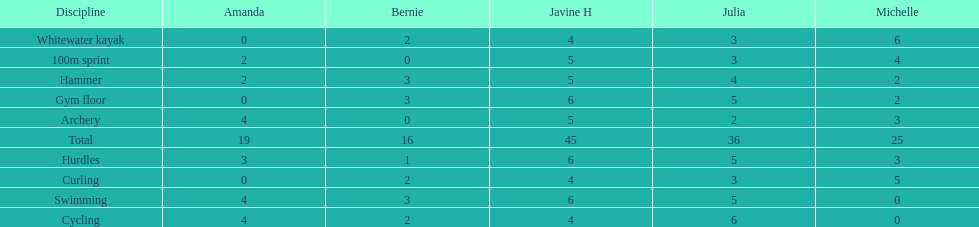What is the average score on 100m sprint? 2.8. Can you parse all the data within this table? {'header': ['Discipline', 'Amanda', 'Bernie', 'Javine H', 'Julia', 'Michelle'], 'rows': [['Whitewater kayak', '0', '2', '4', '3', '6'], ['100m sprint', '2', '0', '5', '3', '4'], ['Hammer', '2', '3', '5', '4', '2'], ['Gym floor', '0', '3', '6', '5', '2'], ['Archery', '4', '0', '5', '2', '3'], ['Total', '19', '16', '45', '36', '25'], ['Hurdles', '3', '1', '6', '5', '3'], ['Curling', '0', '2', '4', '3', '5'], ['Swimming', '4', '3', '6', '5', '0'], ['Cycling', '4', '2', '4', '6', '0']]} 